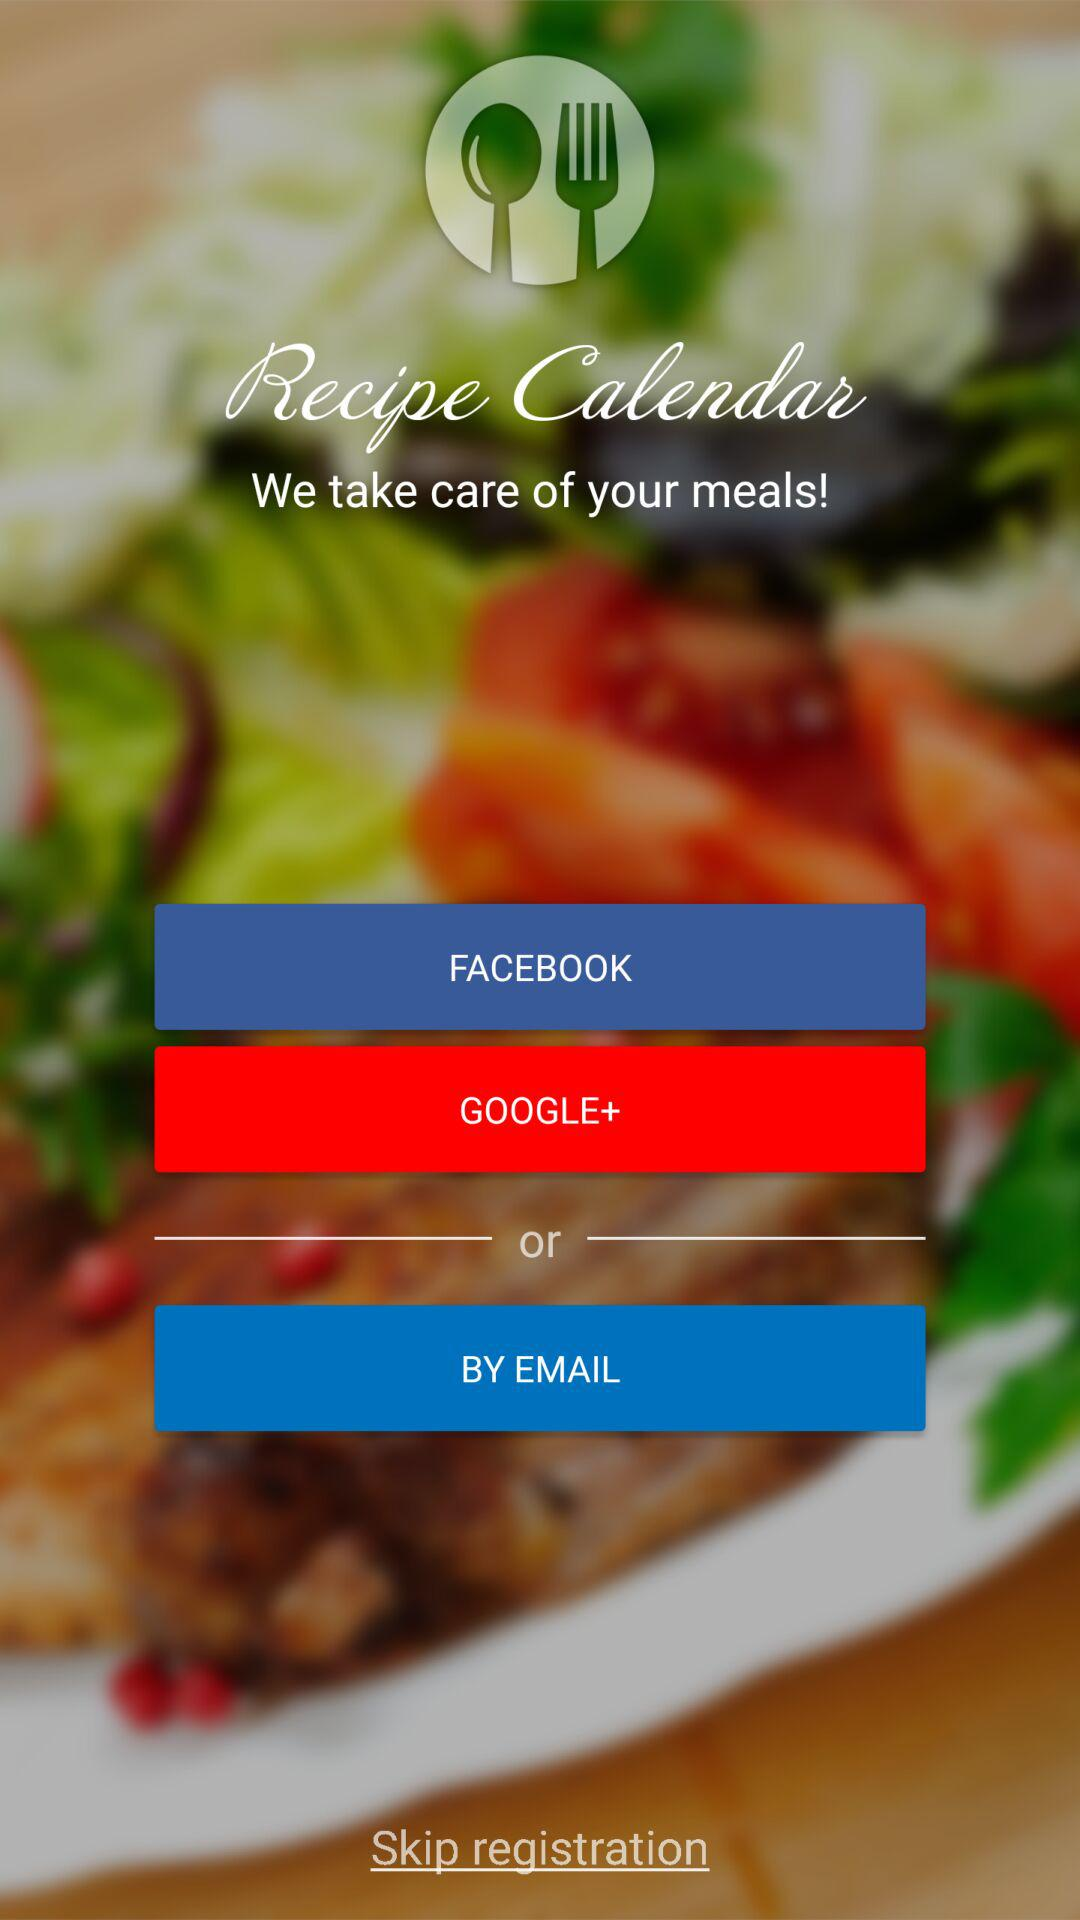Who is this application powered by?
When the provided information is insufficient, respond with <no answer>. <no answer> 